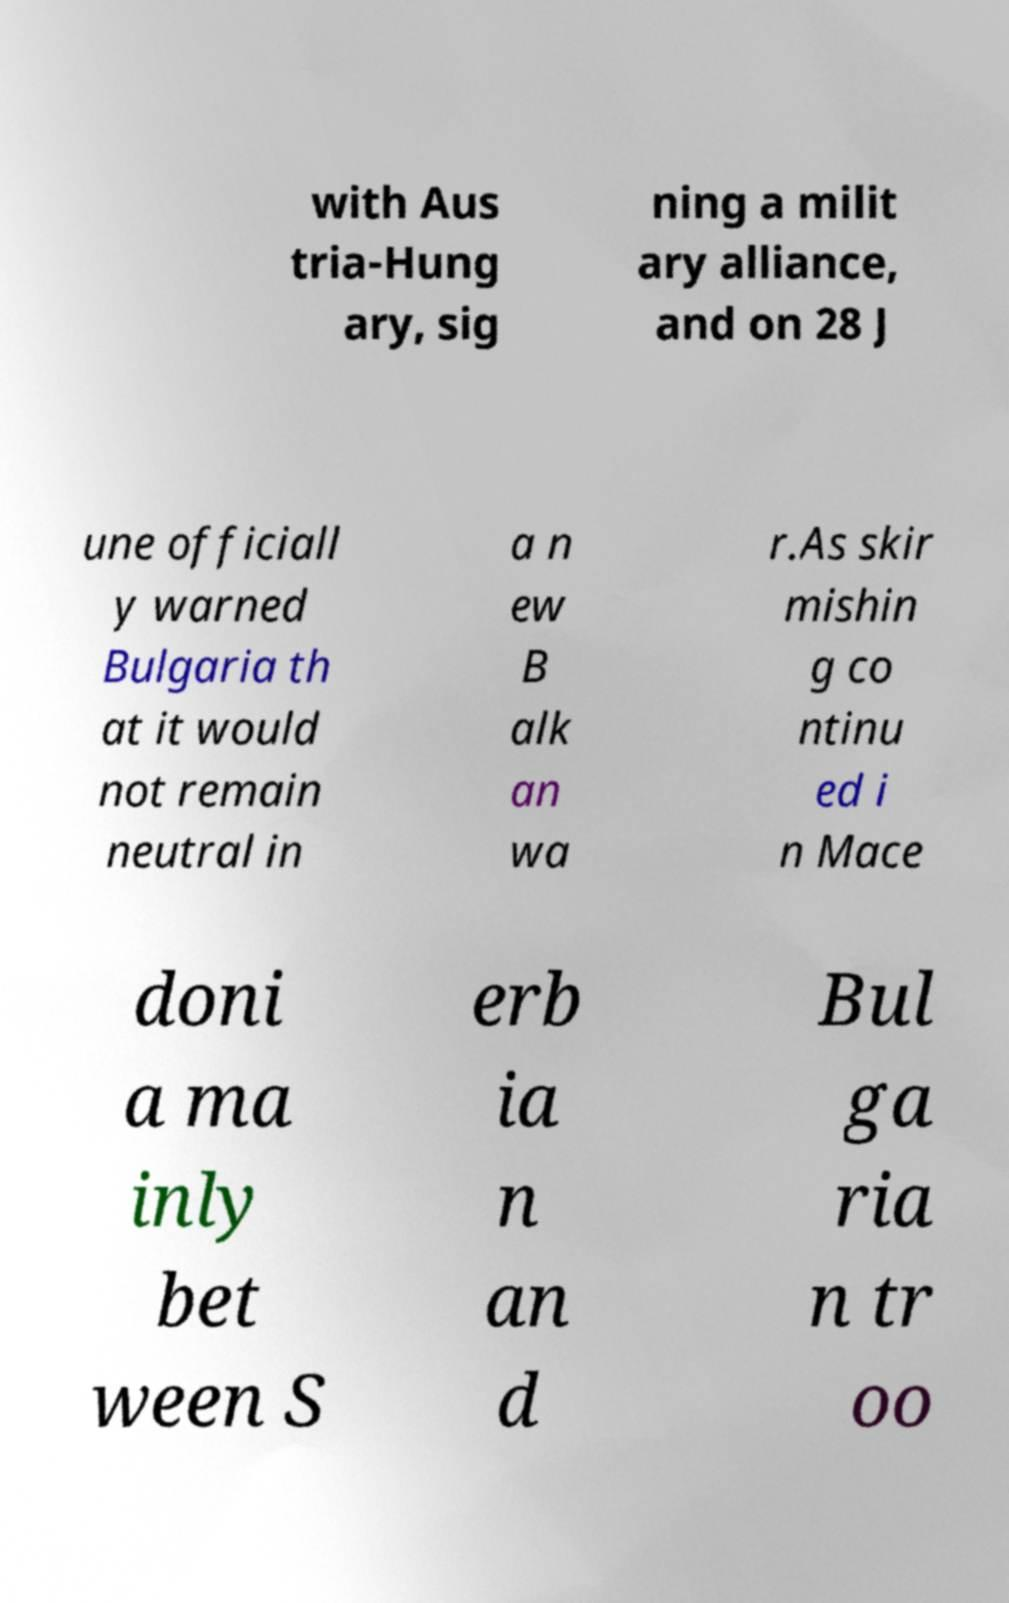Could you assist in decoding the text presented in this image and type it out clearly? with Aus tria-Hung ary, sig ning a milit ary alliance, and on 28 J une officiall y warned Bulgaria th at it would not remain neutral in a n ew B alk an wa r.As skir mishin g co ntinu ed i n Mace doni a ma inly bet ween S erb ia n an d Bul ga ria n tr oo 